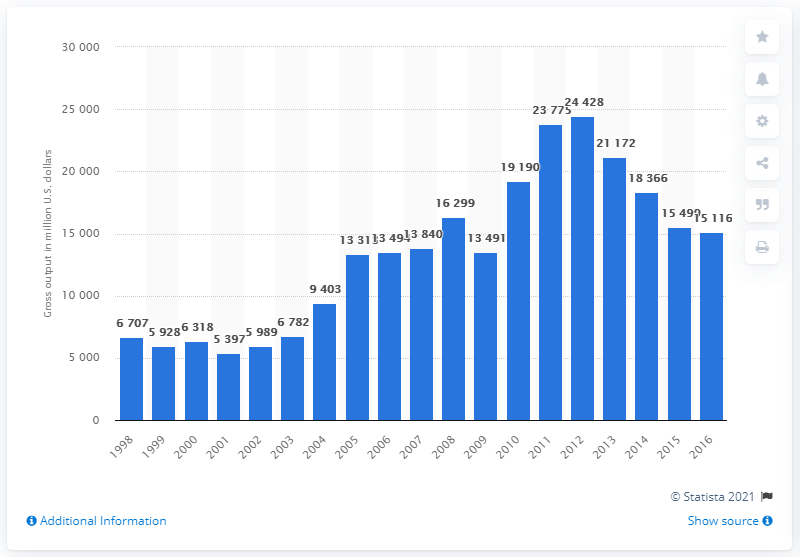Specify some key components in this picture. In 2016, the gross output of the iron, gold, silver, and other metal ore mining sector was $151,16. The gross output of the iron, gold, silver, and other metal ore mining sector in 1998 was 6,707. 